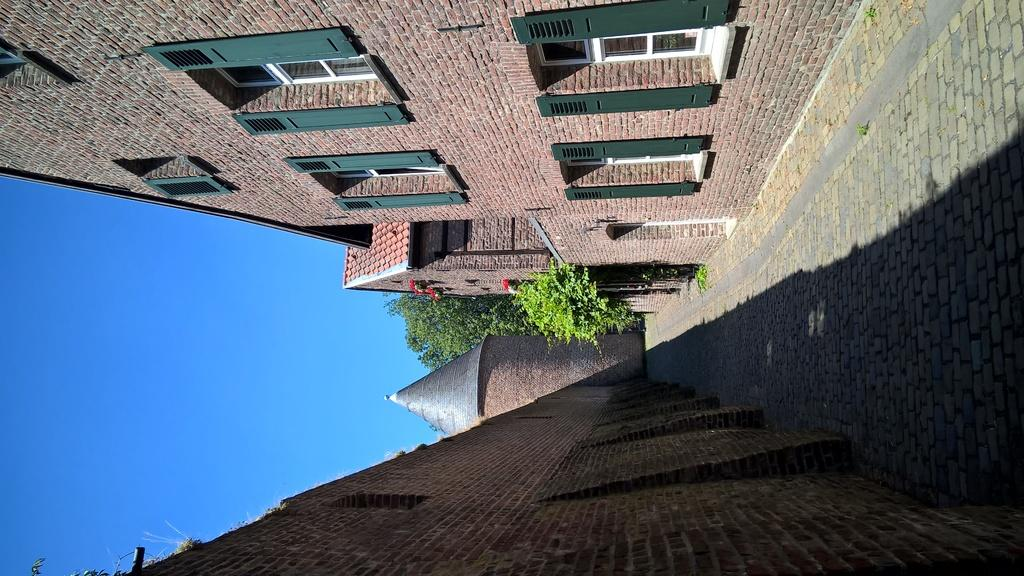What is a distinctive feature of the buildings in the image? The buildings in the image have green windows. What can be seen in the middle of the image? There is a walkway in the center of the image. What type of vegetation is visible at the back of the image? There are trees at the back of the image. How many boats can be seen in the image? There are no boats present in the image. Is there a swing visible in the image? There is no swing present in the image. 